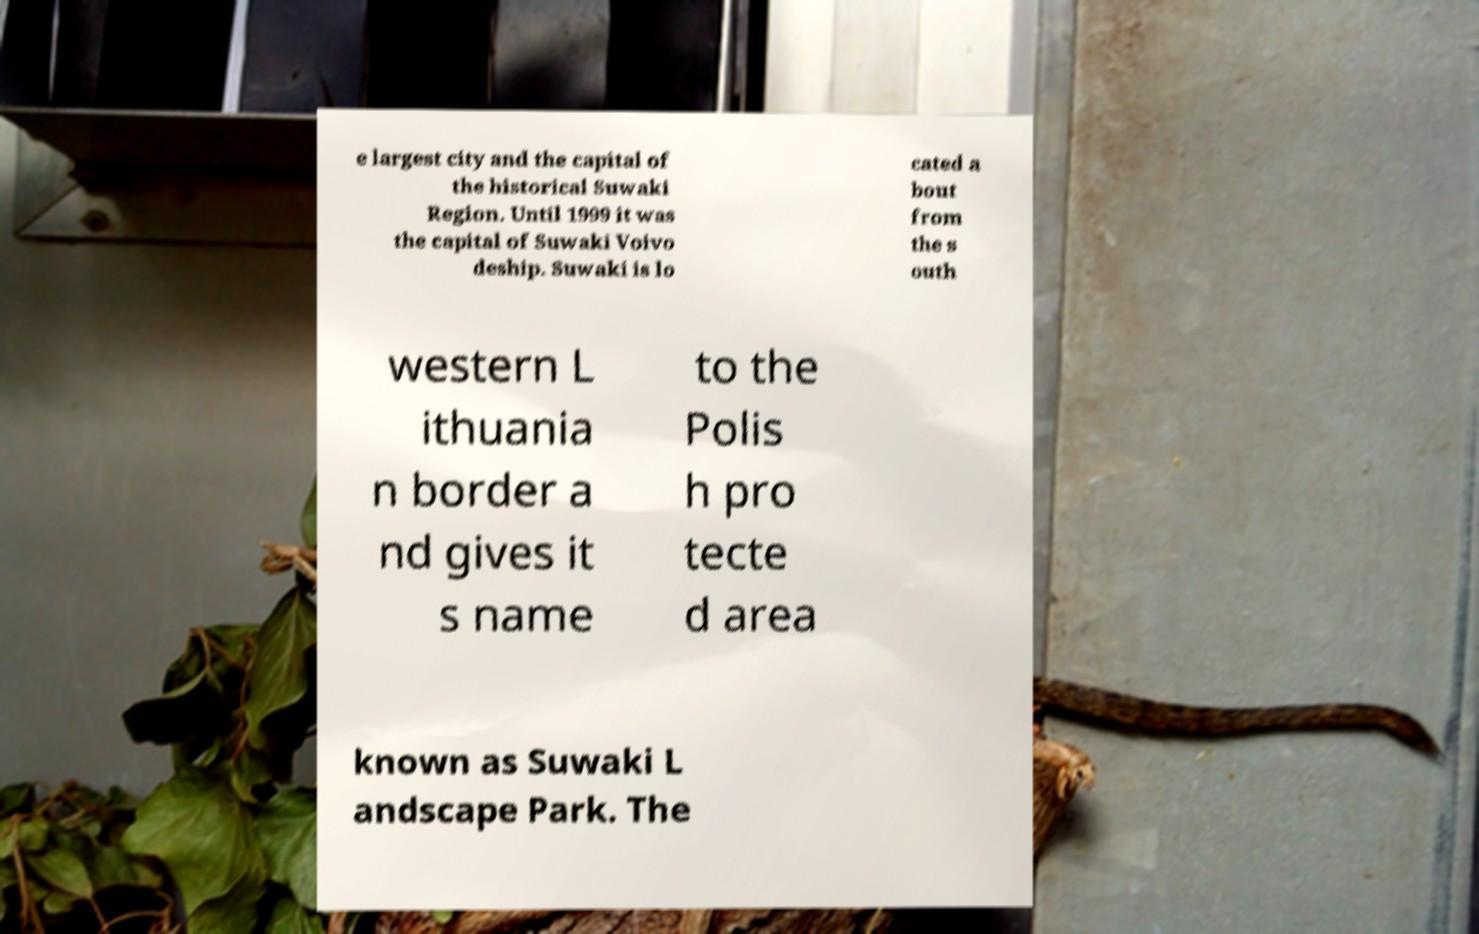For documentation purposes, I need the text within this image transcribed. Could you provide that? e largest city and the capital of the historical Suwaki Region. Until 1999 it was the capital of Suwaki Voivo deship. Suwaki is lo cated a bout from the s outh western L ithuania n border a nd gives it s name to the Polis h pro tecte d area known as Suwaki L andscape Park. The 